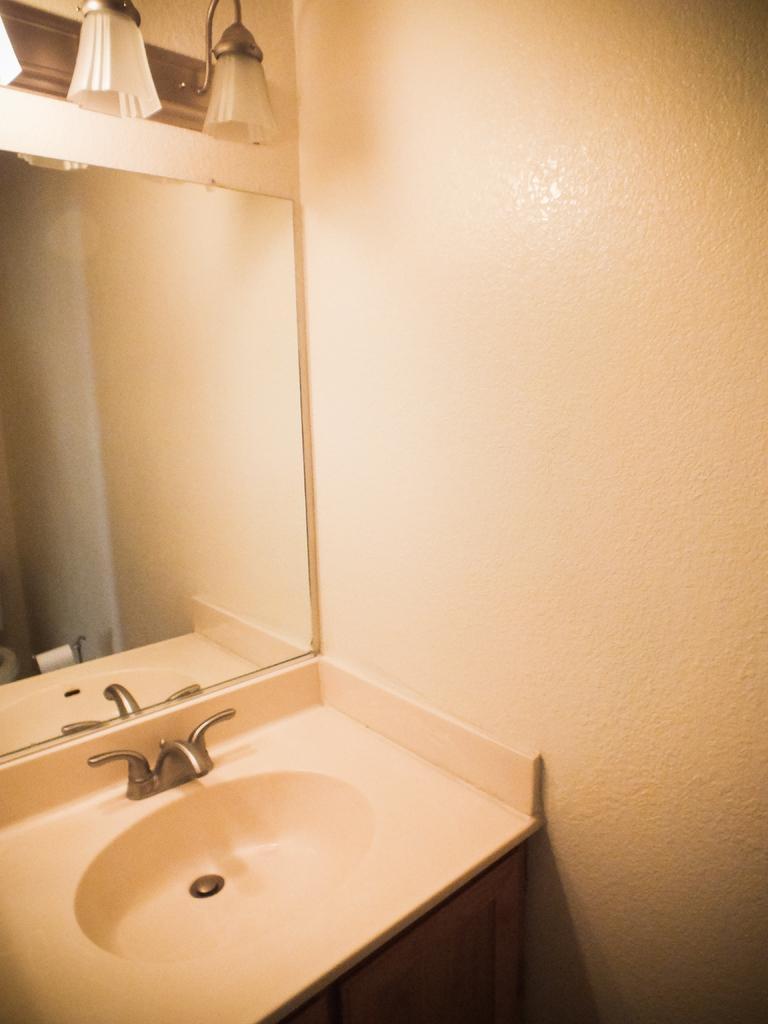Describe this image in one or two sentences. In this image, we can see a sink and there is a mirror. At the top, there are lights and in the background, there is a wall. 